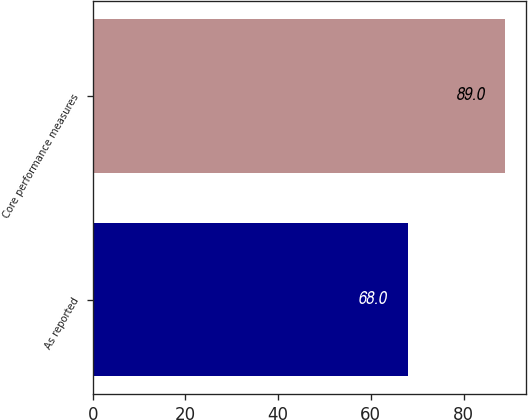<chart> <loc_0><loc_0><loc_500><loc_500><bar_chart><fcel>As reported<fcel>Core performance measures<nl><fcel>68<fcel>89<nl></chart> 